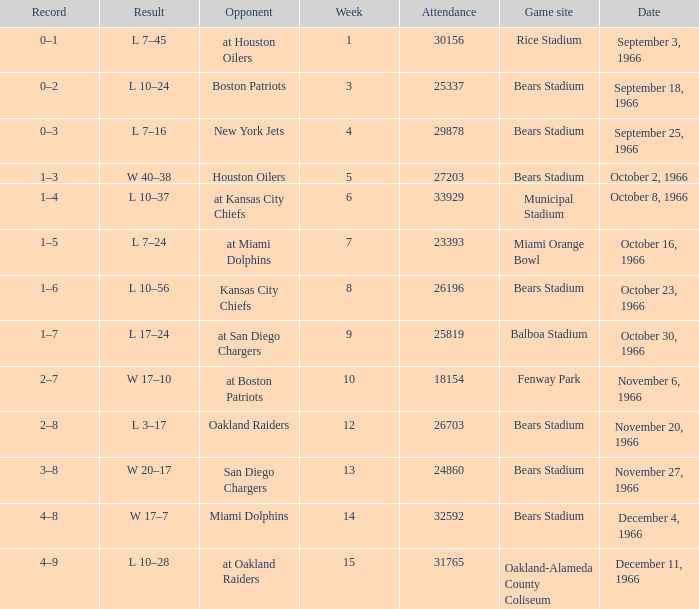What was the date of the game when the opponent was the Miami Dolphins? December 4, 1966. 